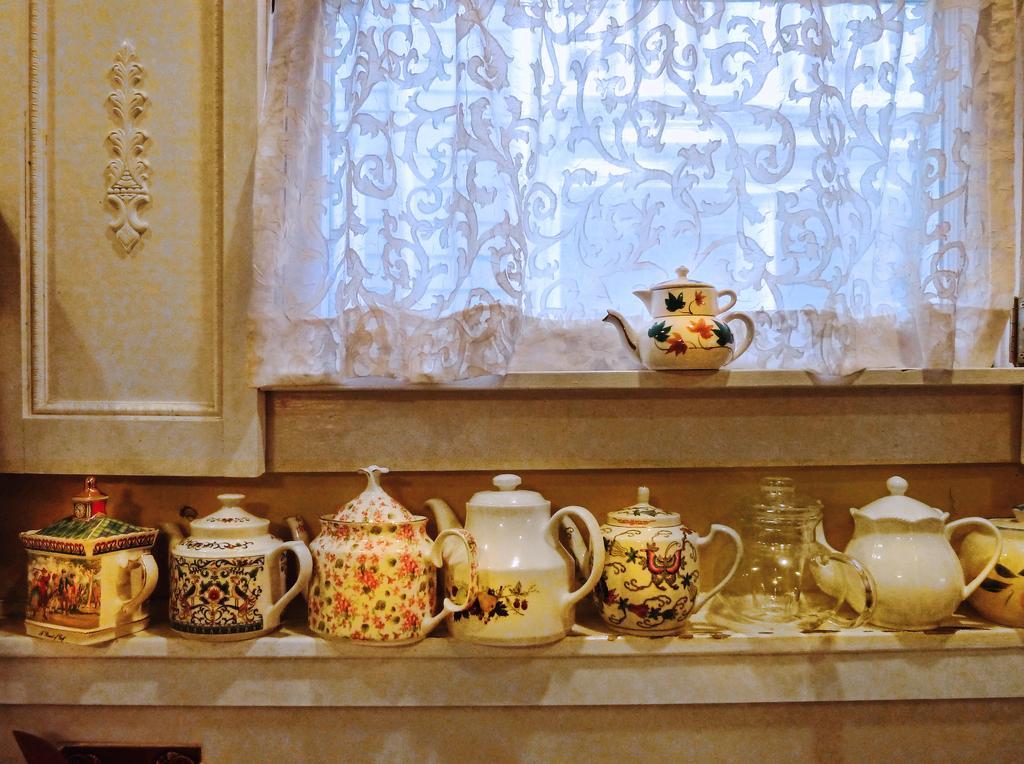Please provide a concise description of this image. This picture shows few kettle jars and we see a window and a curtain to it. 